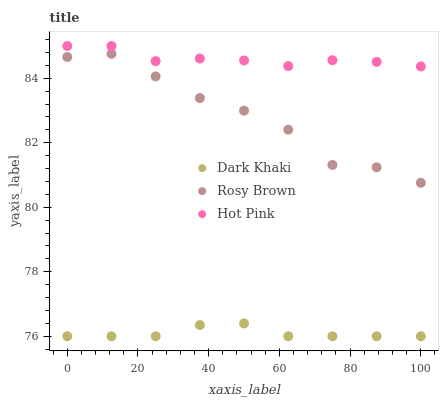Does Dark Khaki have the minimum area under the curve?
Answer yes or no. Yes. Does Hot Pink have the maximum area under the curve?
Answer yes or no. Yes. Does Rosy Brown have the minimum area under the curve?
Answer yes or no. No. Does Rosy Brown have the maximum area under the curve?
Answer yes or no. No. Is Dark Khaki the smoothest?
Answer yes or no. Yes. Is Rosy Brown the roughest?
Answer yes or no. Yes. Is Hot Pink the smoothest?
Answer yes or no. No. Is Hot Pink the roughest?
Answer yes or no. No. Does Dark Khaki have the lowest value?
Answer yes or no. Yes. Does Rosy Brown have the lowest value?
Answer yes or no. No. Does Hot Pink have the highest value?
Answer yes or no. Yes. Does Rosy Brown have the highest value?
Answer yes or no. No. Is Dark Khaki less than Hot Pink?
Answer yes or no. Yes. Is Hot Pink greater than Dark Khaki?
Answer yes or no. Yes. Does Dark Khaki intersect Hot Pink?
Answer yes or no. No. 